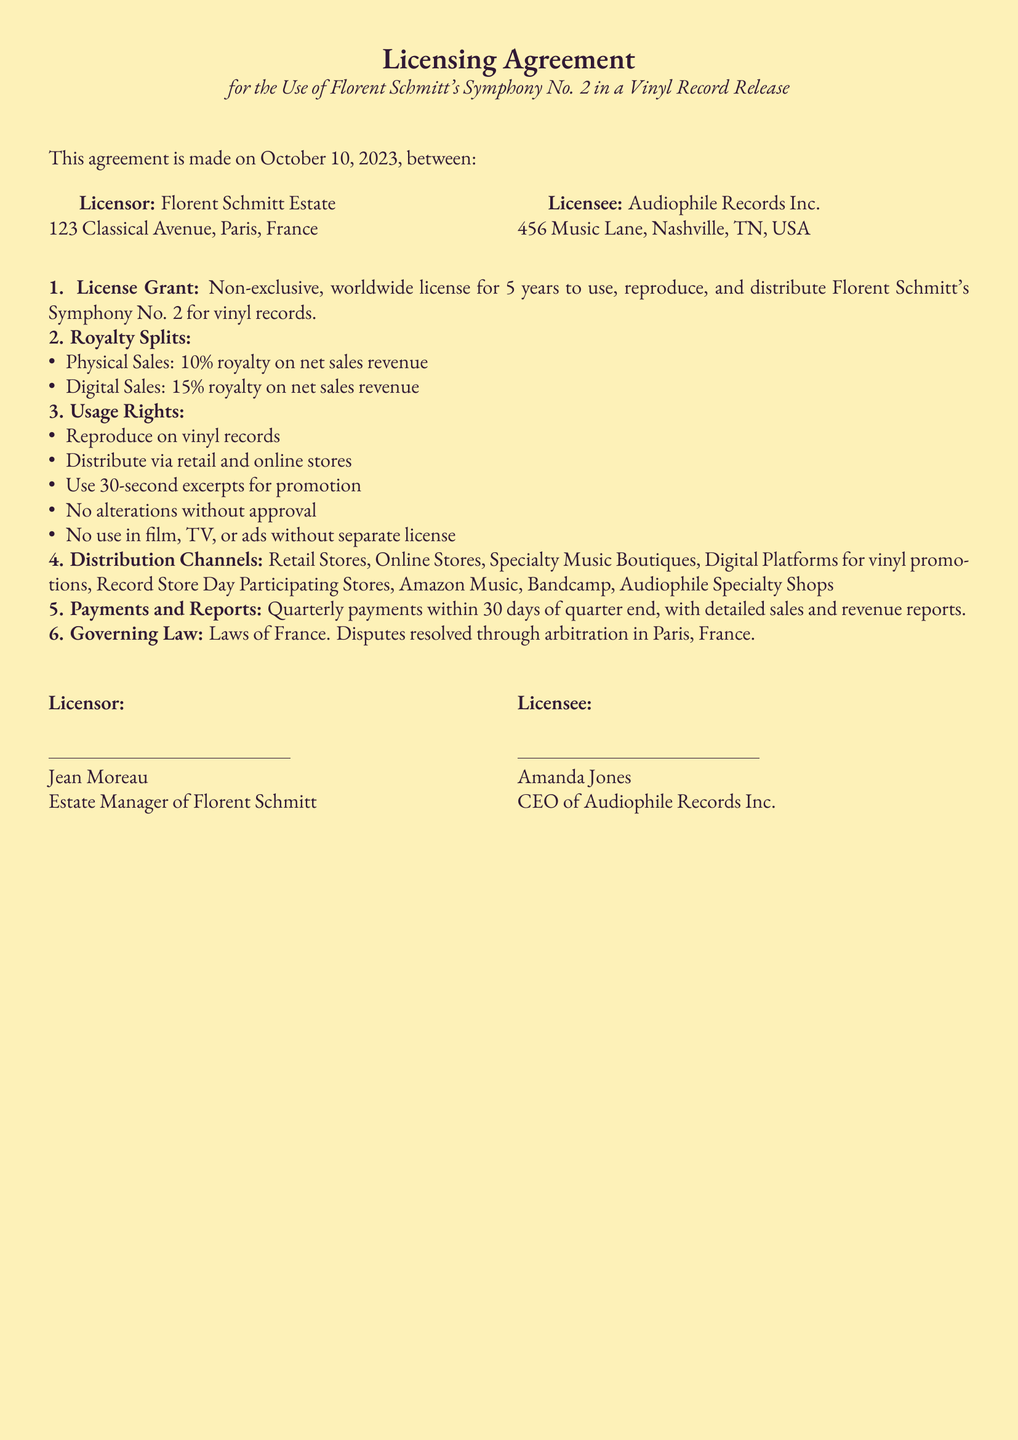What is the Licensor's name? The Licensor is identified as the Florent Schmitt Estate in the document.
Answer: Florent Schmitt Estate What is the total duration of the license? The license grant duration specified in the document is five years.
Answer: 5 years What percentage royalty does the Licensee receive from digital sales? The royalty split for digital sales mentioned in the document is 15 percent.
Answer: 15% Which city governs the contract? The document specifies that the governing law is the laws of France, and arbitration occurs in Paris.
Answer: Paris What rights are granted for promotion? The document states that up to 30-second excerpts may be used for promotional purposes.
Answer: 30-second excerpts Who is the Estate Manager for the Licensor? The document lists Jean Moreau as the Estate Manager of Florent Schmitt.
Answer: Jean Moreau What is one of the distribution channels mentioned? The document provides various distribution channels, one of which is online stores.
Answer: Online Stores What must the Licensee obtain for alterations? According to the document, no alterations can be made without prior approval from the Licensor.
Answer: Approval 